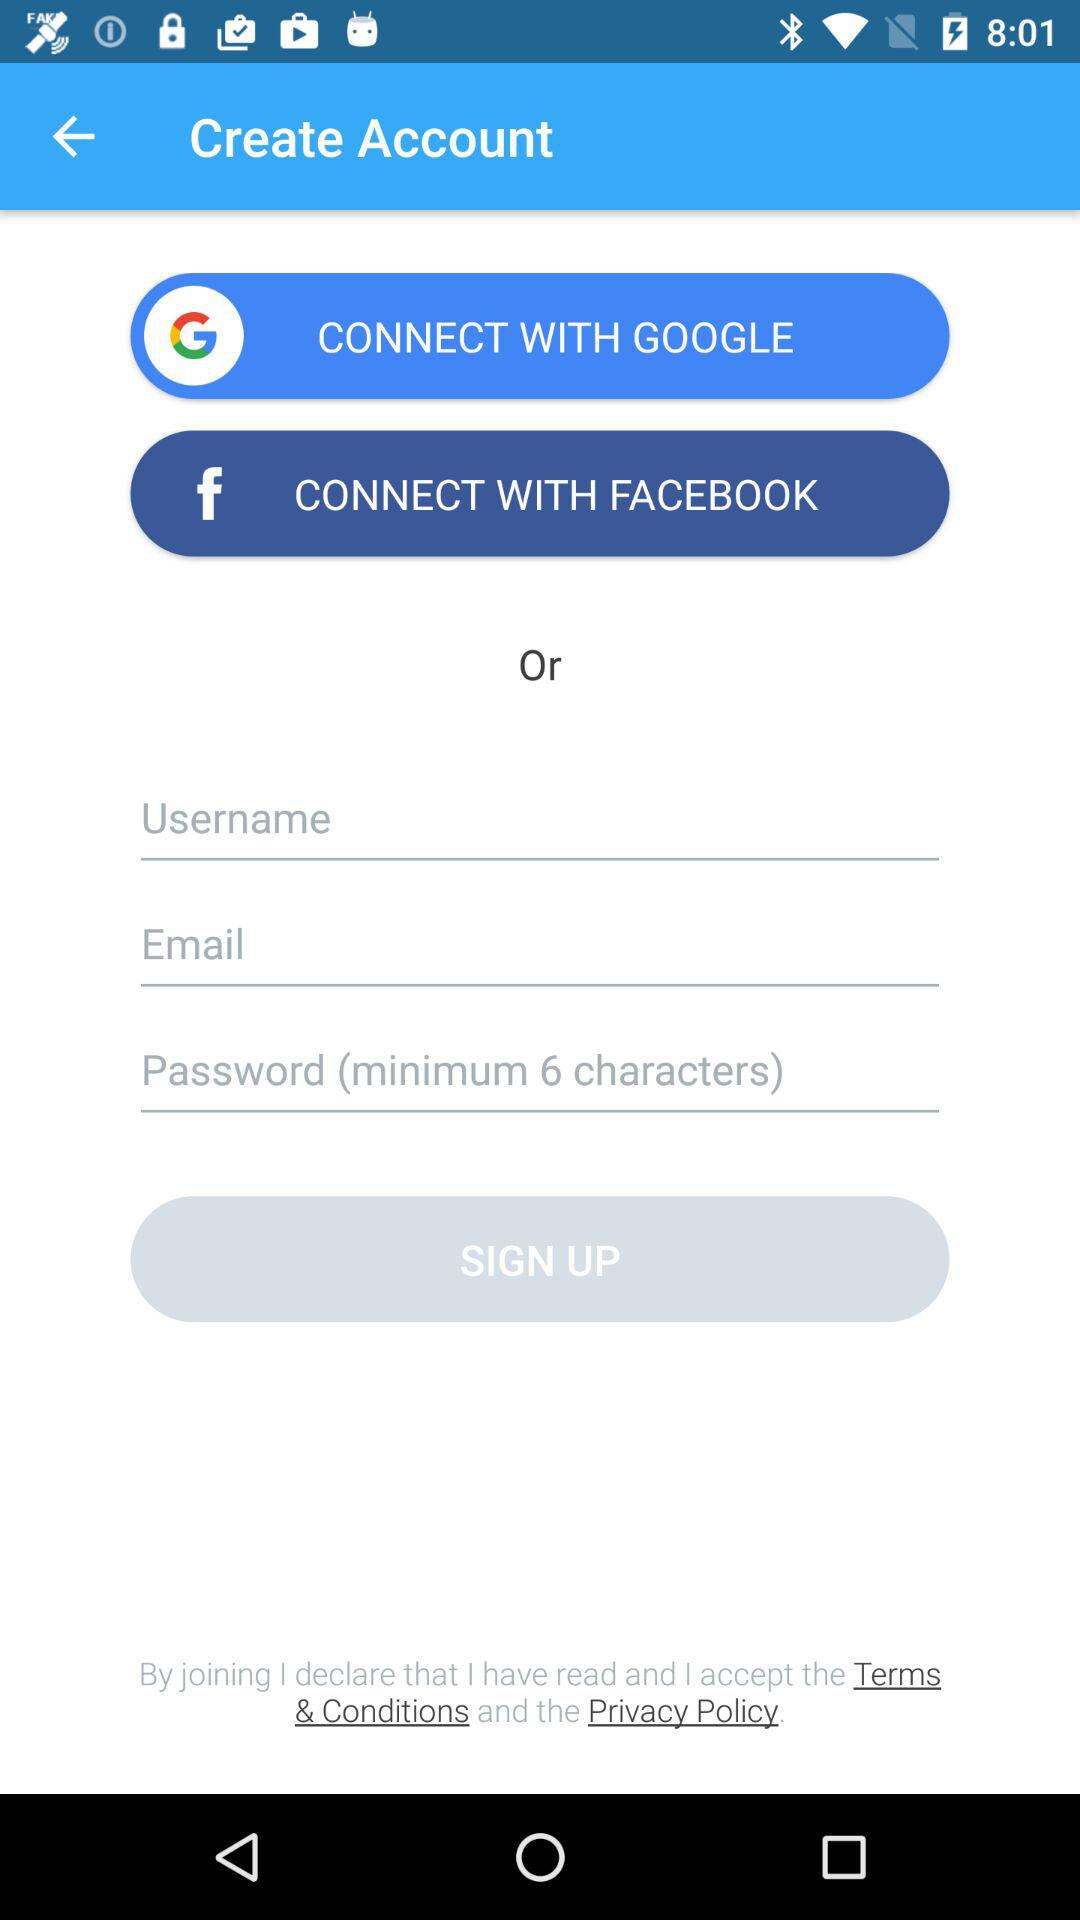How many input fields are there for creating an account?
Answer the question using a single word or phrase. 3 